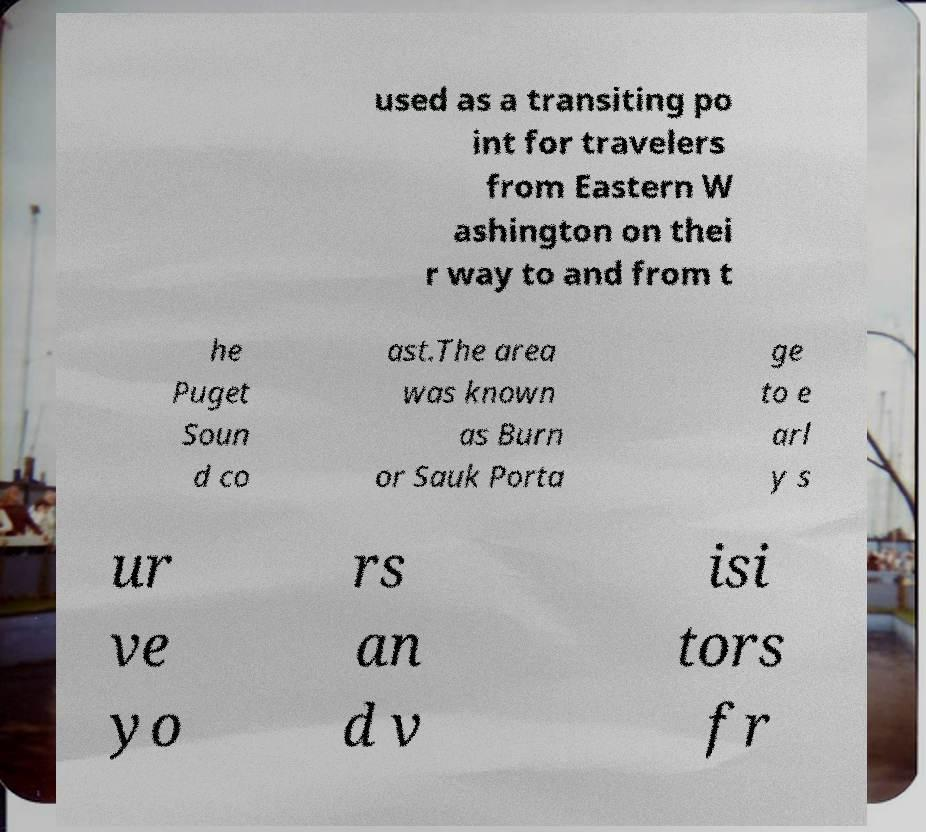Could you extract and type out the text from this image? used as a transiting po int for travelers from Eastern W ashington on thei r way to and from t he Puget Soun d co ast.The area was known as Burn or Sauk Porta ge to e arl y s ur ve yo rs an d v isi tors fr 